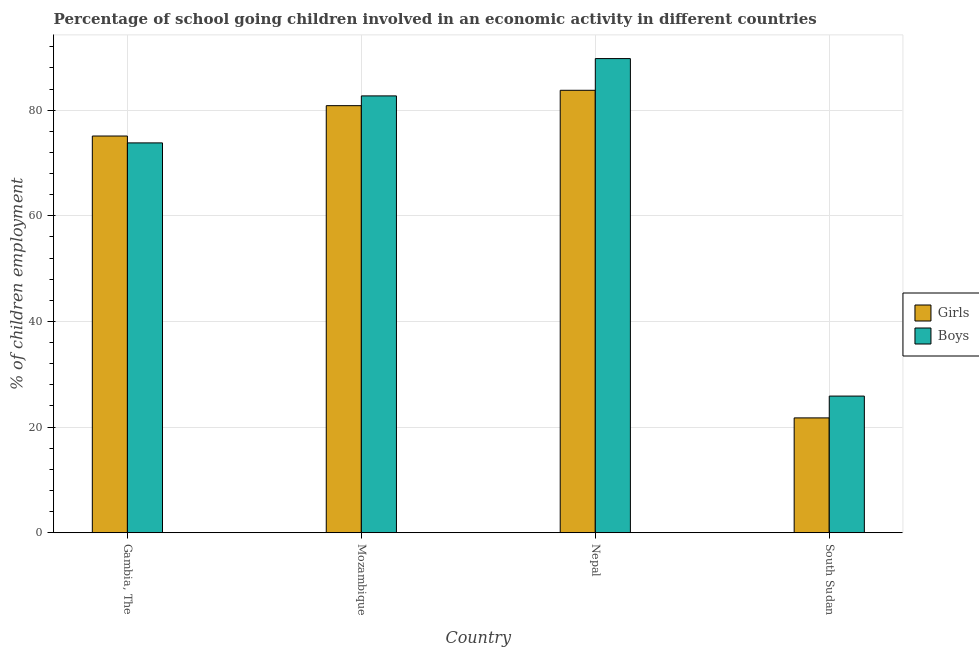How many different coloured bars are there?
Your answer should be compact. 2. How many groups of bars are there?
Provide a succinct answer. 4. Are the number of bars per tick equal to the number of legend labels?
Give a very brief answer. Yes. Are the number of bars on each tick of the X-axis equal?
Offer a very short reply. Yes. How many bars are there on the 4th tick from the left?
Your answer should be compact. 2. How many bars are there on the 1st tick from the right?
Make the answer very short. 2. What is the label of the 3rd group of bars from the left?
Provide a short and direct response. Nepal. In how many cases, is the number of bars for a given country not equal to the number of legend labels?
Keep it short and to the point. 0. What is the percentage of school going girls in Mozambique?
Provide a succinct answer. 80.85. Across all countries, what is the maximum percentage of school going boys?
Offer a very short reply. 89.76. Across all countries, what is the minimum percentage of school going girls?
Ensure brevity in your answer.  21.74. In which country was the percentage of school going girls maximum?
Offer a very short reply. Nepal. In which country was the percentage of school going girls minimum?
Keep it short and to the point. South Sudan. What is the total percentage of school going girls in the graph?
Your response must be concise. 261.45. What is the difference between the percentage of school going girls in Mozambique and that in Nepal?
Your response must be concise. -2.91. What is the difference between the percentage of school going girls in Nepal and the percentage of school going boys in Mozambique?
Ensure brevity in your answer.  1.06. What is the average percentage of school going girls per country?
Make the answer very short. 65.36. What is the difference between the percentage of school going girls and percentage of school going boys in Nepal?
Give a very brief answer. -6. What is the ratio of the percentage of school going girls in Gambia, The to that in South Sudan?
Your answer should be compact. 3.45. Is the percentage of school going boys in Mozambique less than that in Nepal?
Your response must be concise. Yes. Is the difference between the percentage of school going girls in Gambia, The and Mozambique greater than the difference between the percentage of school going boys in Gambia, The and Mozambique?
Ensure brevity in your answer.  Yes. What is the difference between the highest and the second highest percentage of school going girls?
Provide a short and direct response. 2.91. What is the difference between the highest and the lowest percentage of school going girls?
Keep it short and to the point. 62.02. In how many countries, is the percentage of school going boys greater than the average percentage of school going boys taken over all countries?
Make the answer very short. 3. What does the 2nd bar from the left in Gambia, The represents?
Provide a short and direct response. Boys. What does the 1st bar from the right in Mozambique represents?
Give a very brief answer. Boys. How many bars are there?
Your answer should be very brief. 8. How many countries are there in the graph?
Keep it short and to the point. 4. What is the difference between two consecutive major ticks on the Y-axis?
Make the answer very short. 20. Does the graph contain grids?
Keep it short and to the point. Yes. How are the legend labels stacked?
Your answer should be compact. Vertical. What is the title of the graph?
Keep it short and to the point. Percentage of school going children involved in an economic activity in different countries. What is the label or title of the X-axis?
Make the answer very short. Country. What is the label or title of the Y-axis?
Offer a terse response. % of children employment. What is the % of children employment in Girls in Gambia, The?
Offer a very short reply. 75.1. What is the % of children employment of Boys in Gambia, The?
Make the answer very short. 73.8. What is the % of children employment in Girls in Mozambique?
Keep it short and to the point. 80.85. What is the % of children employment of Boys in Mozambique?
Ensure brevity in your answer.  82.7. What is the % of children employment in Girls in Nepal?
Provide a short and direct response. 83.76. What is the % of children employment in Boys in Nepal?
Make the answer very short. 89.76. What is the % of children employment in Girls in South Sudan?
Give a very brief answer. 21.74. What is the % of children employment of Boys in South Sudan?
Offer a terse response. 25.87. Across all countries, what is the maximum % of children employment in Girls?
Keep it short and to the point. 83.76. Across all countries, what is the maximum % of children employment of Boys?
Your answer should be very brief. 89.76. Across all countries, what is the minimum % of children employment in Girls?
Keep it short and to the point. 21.74. Across all countries, what is the minimum % of children employment of Boys?
Provide a short and direct response. 25.87. What is the total % of children employment in Girls in the graph?
Keep it short and to the point. 261.45. What is the total % of children employment of Boys in the graph?
Provide a succinct answer. 272.13. What is the difference between the % of children employment in Girls in Gambia, The and that in Mozambique?
Your answer should be very brief. -5.75. What is the difference between the % of children employment of Boys in Gambia, The and that in Mozambique?
Keep it short and to the point. -8.9. What is the difference between the % of children employment of Girls in Gambia, The and that in Nepal?
Provide a short and direct response. -8.66. What is the difference between the % of children employment in Boys in Gambia, The and that in Nepal?
Keep it short and to the point. -15.96. What is the difference between the % of children employment of Girls in Gambia, The and that in South Sudan?
Your answer should be compact. 53.36. What is the difference between the % of children employment of Boys in Gambia, The and that in South Sudan?
Ensure brevity in your answer.  47.93. What is the difference between the % of children employment in Girls in Mozambique and that in Nepal?
Provide a succinct answer. -2.91. What is the difference between the % of children employment of Boys in Mozambique and that in Nepal?
Ensure brevity in your answer.  -7.07. What is the difference between the % of children employment in Girls in Mozambique and that in South Sudan?
Your answer should be compact. 59.11. What is the difference between the % of children employment of Boys in Mozambique and that in South Sudan?
Provide a succinct answer. 56.83. What is the difference between the % of children employment of Girls in Nepal and that in South Sudan?
Offer a very short reply. 62.02. What is the difference between the % of children employment of Boys in Nepal and that in South Sudan?
Give a very brief answer. 63.9. What is the difference between the % of children employment of Girls in Gambia, The and the % of children employment of Boys in Mozambique?
Keep it short and to the point. -7.6. What is the difference between the % of children employment of Girls in Gambia, The and the % of children employment of Boys in Nepal?
Offer a terse response. -14.66. What is the difference between the % of children employment of Girls in Gambia, The and the % of children employment of Boys in South Sudan?
Offer a terse response. 49.23. What is the difference between the % of children employment of Girls in Mozambique and the % of children employment of Boys in Nepal?
Ensure brevity in your answer.  -8.91. What is the difference between the % of children employment of Girls in Mozambique and the % of children employment of Boys in South Sudan?
Make the answer very short. 54.98. What is the difference between the % of children employment of Girls in Nepal and the % of children employment of Boys in South Sudan?
Give a very brief answer. 57.89. What is the average % of children employment of Girls per country?
Offer a terse response. 65.36. What is the average % of children employment of Boys per country?
Your response must be concise. 68.03. What is the difference between the % of children employment in Girls and % of children employment in Boys in Gambia, The?
Your answer should be compact. 1.3. What is the difference between the % of children employment in Girls and % of children employment in Boys in Mozambique?
Offer a very short reply. -1.85. What is the difference between the % of children employment of Girls and % of children employment of Boys in Nepal?
Provide a succinct answer. -6. What is the difference between the % of children employment of Girls and % of children employment of Boys in South Sudan?
Ensure brevity in your answer.  -4.13. What is the ratio of the % of children employment in Girls in Gambia, The to that in Mozambique?
Your answer should be very brief. 0.93. What is the ratio of the % of children employment in Boys in Gambia, The to that in Mozambique?
Offer a terse response. 0.89. What is the ratio of the % of children employment in Girls in Gambia, The to that in Nepal?
Your answer should be very brief. 0.9. What is the ratio of the % of children employment of Boys in Gambia, The to that in Nepal?
Your response must be concise. 0.82. What is the ratio of the % of children employment of Girls in Gambia, The to that in South Sudan?
Give a very brief answer. 3.45. What is the ratio of the % of children employment in Boys in Gambia, The to that in South Sudan?
Make the answer very short. 2.85. What is the ratio of the % of children employment in Girls in Mozambique to that in Nepal?
Keep it short and to the point. 0.97. What is the ratio of the % of children employment of Boys in Mozambique to that in Nepal?
Offer a very short reply. 0.92. What is the ratio of the % of children employment of Girls in Mozambique to that in South Sudan?
Provide a succinct answer. 3.72. What is the ratio of the % of children employment of Boys in Mozambique to that in South Sudan?
Your answer should be compact. 3.2. What is the ratio of the % of children employment of Girls in Nepal to that in South Sudan?
Offer a very short reply. 3.85. What is the ratio of the % of children employment of Boys in Nepal to that in South Sudan?
Offer a very short reply. 3.47. What is the difference between the highest and the second highest % of children employment of Girls?
Keep it short and to the point. 2.91. What is the difference between the highest and the second highest % of children employment of Boys?
Your answer should be very brief. 7.07. What is the difference between the highest and the lowest % of children employment of Girls?
Ensure brevity in your answer.  62.02. What is the difference between the highest and the lowest % of children employment in Boys?
Provide a short and direct response. 63.9. 